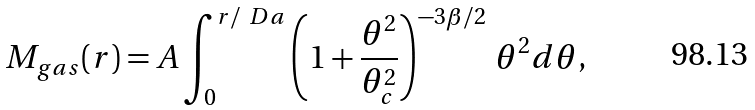Convert formula to latex. <formula><loc_0><loc_0><loc_500><loc_500>M _ { g a s } ( r ) = A \int _ { 0 } ^ { r / \ D a } \left ( 1 + \frac { \theta ^ { 2 } } { \theta _ { c } ^ { 2 } } \right ) ^ { - 3 \beta / 2 } \, \theta ^ { 2 } d \theta ,</formula> 